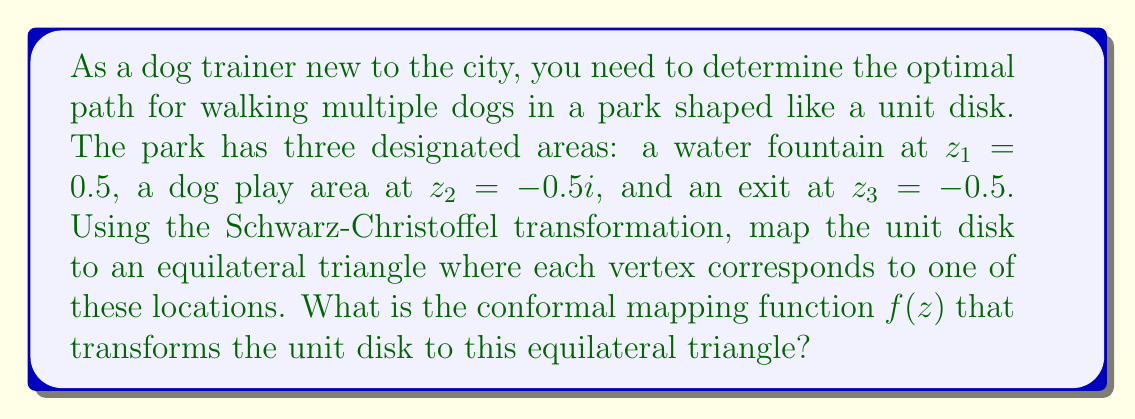Help me with this question. To solve this problem, we'll use the Schwarz-Christoffel formula for mapping the unit disk to an equilateral triangle. The steps are as follows:

1) The Schwarz-Christoffel formula for mapping the unit disk to a polygon is:

   $$f(z) = A \int_0^z \prod_{k=1}^n (1 - \frac{\zeta}{e^{i\theta_k}})^{\alpha_k - 1} d\zeta + B$$

   where $\theta_k$ are the arguments of the pre-vertices on the unit circle, and $\alpha_k$ are the exterior angles of the polygon divided by $\pi$.

2) For an equilateral triangle, all exterior angles are $2\pi/3$, so $\alpha_k - 1 = -1/3$ for all $k$.

3) The pre-vertices on the unit circle corresponding to $z_1$, $z_2$, and $z_3$ are:
   $e^{i\theta_1} = 1$, $e^{i\theta_2} = e^{2\pi i/3}$, and $e^{i\theta_3} = e^{4\pi i/3}$

4) Substituting these into the Schwarz-Christoffel formula:

   $$f(z) = A \int_0^z (1 - \zeta)^{-1/3} (1 - \zeta e^{-2\pi i/3})^{-1/3} (1 - \zeta e^{-4\pi i/3})^{-1/3} d\zeta + B$$

5) This integral can be expressed in terms of the hypergeometric function $_2F_1$:

   $$f(z) = A \cdot z \cdot {_2F_1}(\frac{1}{3}, \frac{2}{3}; 2; z^3) + B$$

6) The constants $A$ and $B$ are determined by the specific size and position of the triangle, but they don't change the essential shape of the mapping.

Therefore, the conformal mapping function from the unit disk to an equilateral triangle is of the form:

$$f(z) = A \cdot z \cdot {_2F_1}(\frac{1}{3}, \frac{2}{3}; 2; z^3) + B$$

where $_2F_1$ is the hypergeometric function.
Answer: $$f(z) = A \cdot z \cdot {_2F_1}(\frac{1}{3}, \frac{2}{3}; 2; z^3) + B$$
where $A$ and $B$ are complex constants, and $_2F_1$ is the hypergeometric function. 